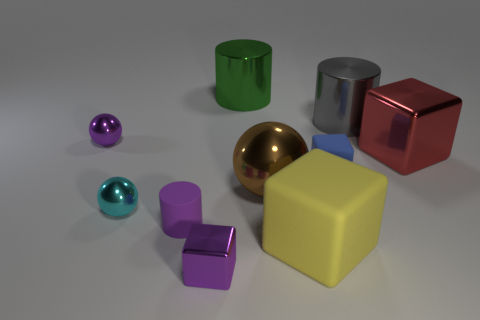What is the small thing that is on the right side of the yellow object made of?
Offer a very short reply. Rubber. There is a tiny block that is the same material as the small cyan object; what color is it?
Keep it short and to the point. Purple. What number of shiny things are red objects or large gray objects?
Provide a short and direct response. 2. What is the shape of the blue thing that is the same size as the cyan metallic ball?
Provide a short and direct response. Cube. How many objects are either rubber cubes that are behind the large yellow block or small spheres behind the blue object?
Your response must be concise. 2. What material is the purple ball that is the same size as the purple cylinder?
Give a very brief answer. Metal. How many other objects are the same material as the brown object?
Make the answer very short. 6. Is the number of blue blocks on the left side of the cyan object the same as the number of blue rubber things that are behind the blue block?
Your answer should be compact. Yes. What number of green things are either large rubber things or tiny metal blocks?
Your answer should be compact. 0. There is a big sphere; does it have the same color as the small block that is in front of the blue thing?
Keep it short and to the point. No. 